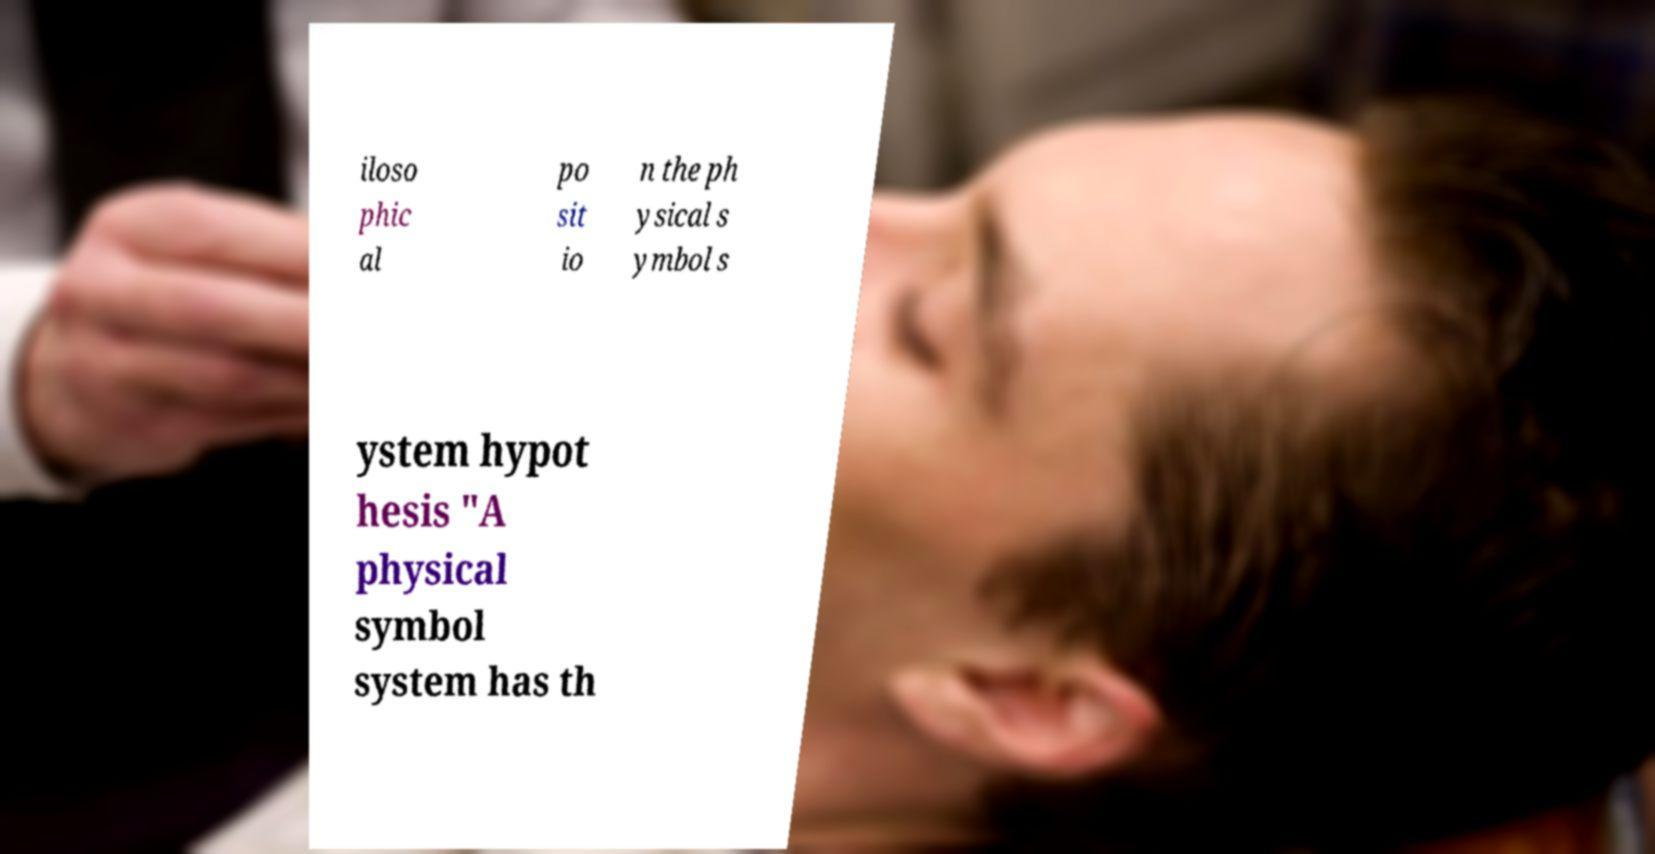For documentation purposes, I need the text within this image transcribed. Could you provide that? iloso phic al po sit io n the ph ysical s ymbol s ystem hypot hesis "A physical symbol system has th 